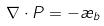<formula> <loc_0><loc_0><loc_500><loc_500>\nabla \cdot P = - \rho _ { b }</formula> 